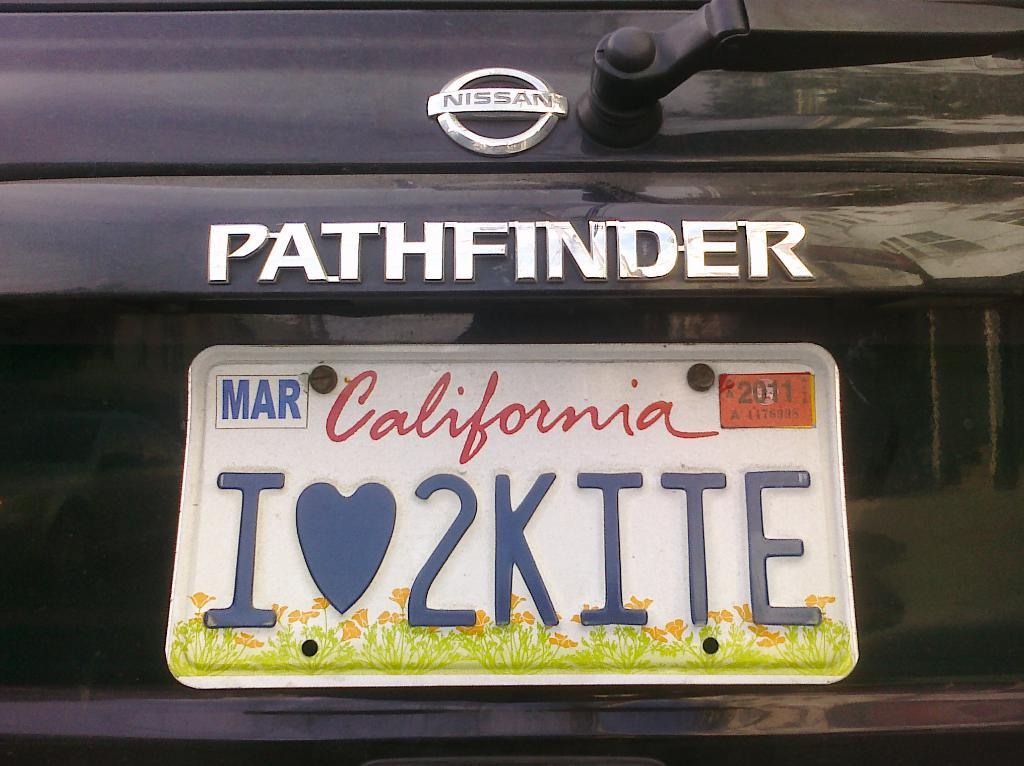<image>
Relay a brief, clear account of the picture shown. White California license plate which says I2KITE on it. 